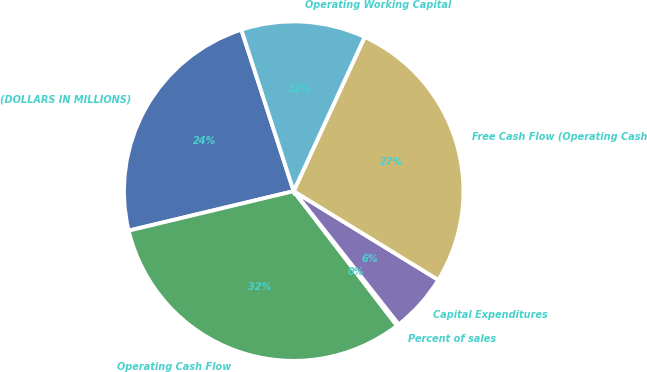Convert chart. <chart><loc_0><loc_0><loc_500><loc_500><pie_chart><fcel>(DOLLARS IN MILLIONS)<fcel>Operating Cash Flow<fcel>Percent of sales<fcel>Capital Expenditures<fcel>Free Cash Flow (Operating Cash<fcel>Operating Working Capital<nl><fcel>23.75%<fcel>31.68%<fcel>0.21%<fcel>5.61%<fcel>26.9%<fcel>11.86%<nl></chart> 